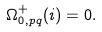Convert formula to latex. <formula><loc_0><loc_0><loc_500><loc_500>\Omega ^ { + } _ { 0 , p q } ( i ) = 0 .</formula> 